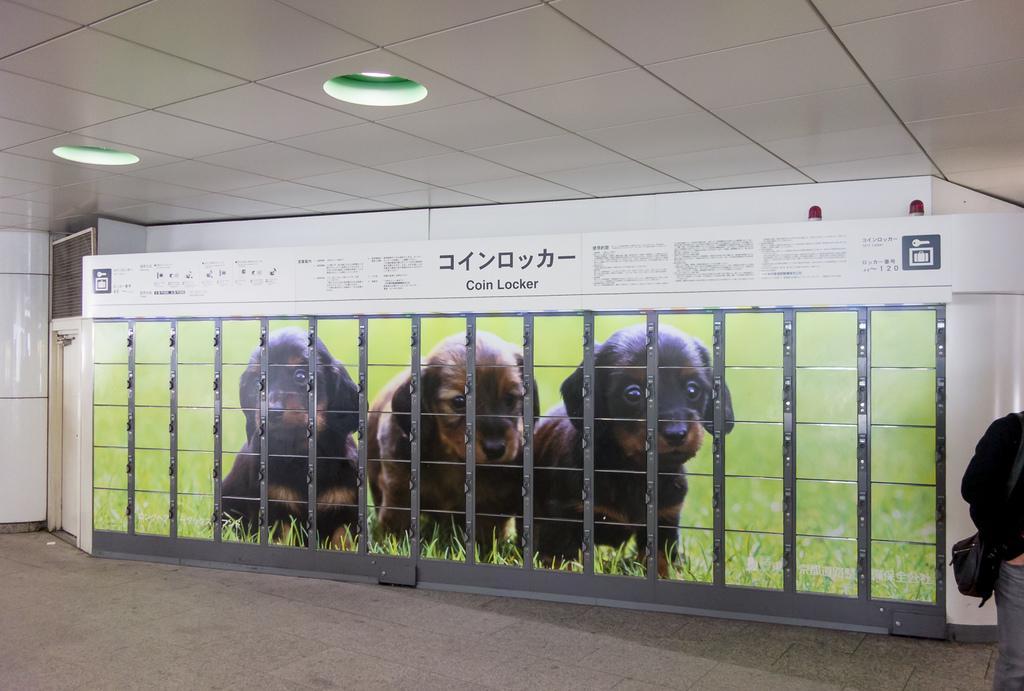Can you describe this image briefly? In this image I see number of posters on which I see 3 dogs and I see the green grass and I see few words written over here and I can also see the lights on the ceiling and I see the floor and I see a person over here. 